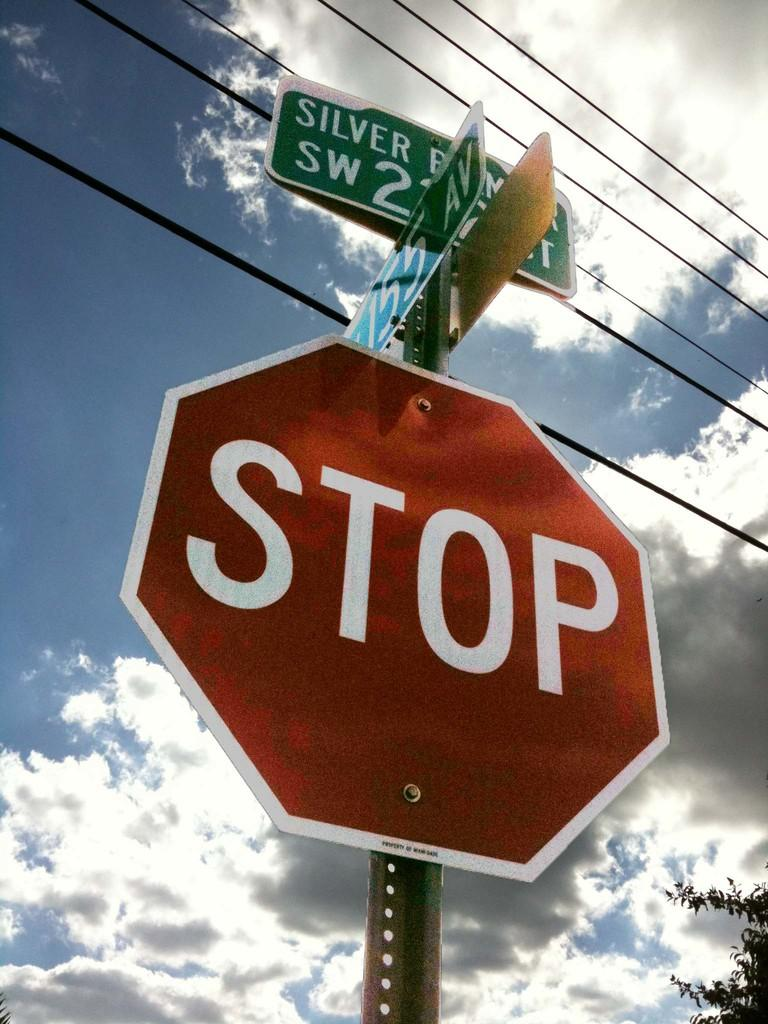What is located in the foreground of the picture? There is a sign board and direction boards in the foreground of the picture. What can be seen at the top of the image? There are cables visible at the top of the image. What is on the right side of the image? There is a tree on the right side of the image. How would you describe the sky in the image? The sky is cloudy in the image. What type of vessel can be seen navigating through the clouds in the image? There is no vessel navigating through the clouds in the image; it only features a sign board, direction boards, cables, a tree, and a cloudy sky. How many fish are visible in the image? There are no fish present in the image. 